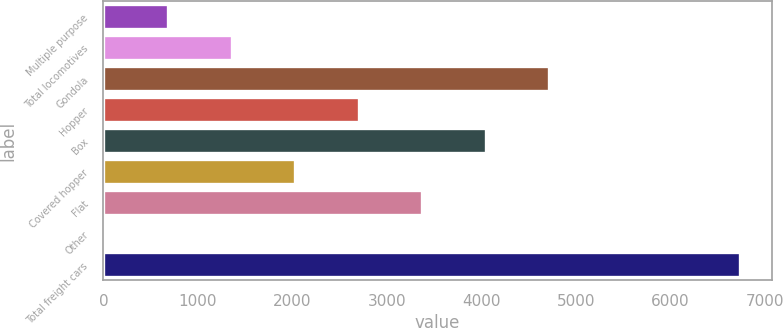<chart> <loc_0><loc_0><loc_500><loc_500><bar_chart><fcel>Multiple purpose<fcel>Total locomotives<fcel>Gondola<fcel>Hopper<fcel>Box<fcel>Covered hopper<fcel>Flat<fcel>Other<fcel>Total freight cars<nl><fcel>686.1<fcel>1358.2<fcel>4718.7<fcel>2702.4<fcel>4046.6<fcel>2030.3<fcel>3374.5<fcel>14<fcel>6735<nl></chart> 